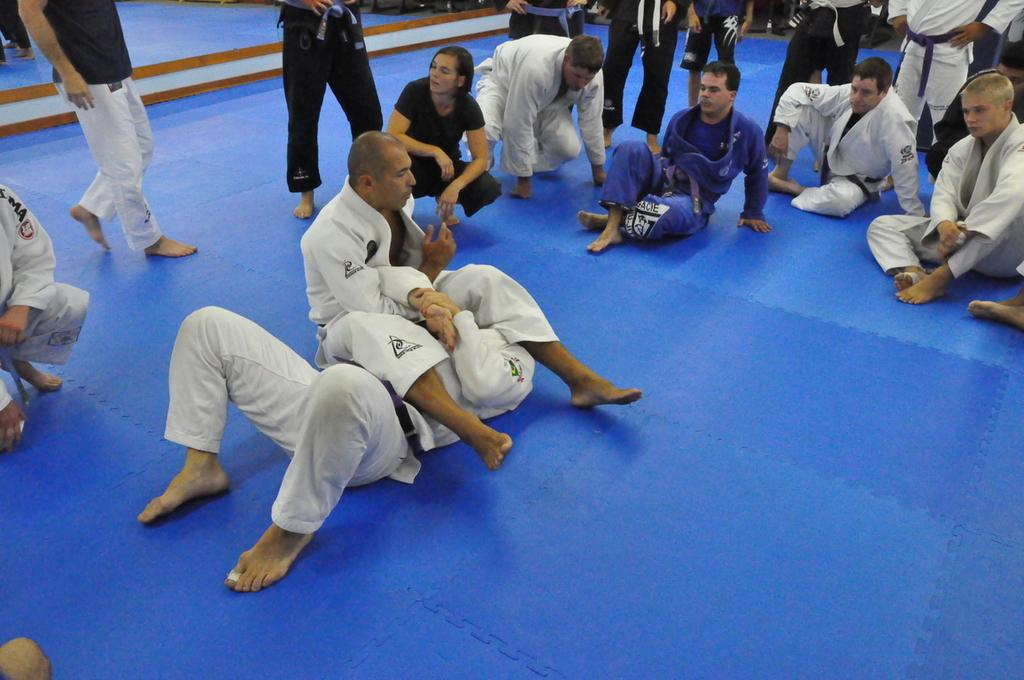What is the color of the mat in the picture? The mat in the picture is blue. What is happening on the mat? There are men on the mat, with some sitting and others standing. What are the men wearing? The men are wearing blue and black karate dresses. What type of fuel is being used by the men in the picture? There is no mention of fuel or any fuel-related activity in the image. The men are wearing karate dresses and are likely practicing martial arts on the mat. 